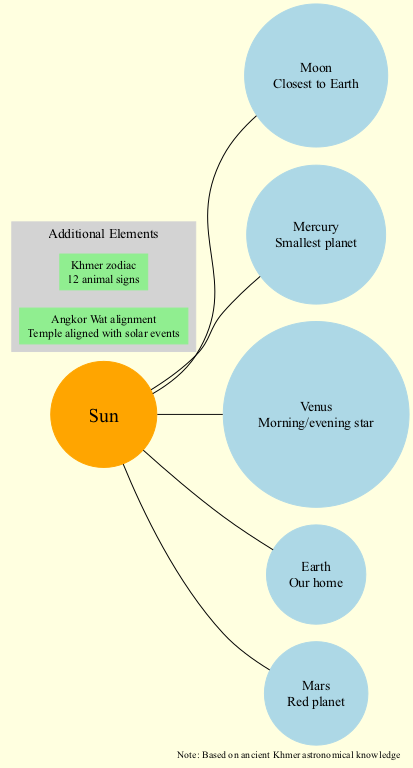What is the position of Venus in the diagram? The diagram indicates the position of Venus as 3. Each celestial body is listed with its corresponding position number, and Venus is clearly marked with position 3.
Answer: 3 How many celestial bodies are depicted in the solar system model? The diagram shows a total of 5 celestial bodies, which includes the Moon, Mercury, Venus, Earth, and Mars. By counting those listed under celestial bodies, we arrive at the total count of 5.
Answer: 5 Which celestial body is described as "Our home"? The Earth is the celestial body described as "Our home." In the diagram, it is explicitly indicated that Earth is associated with this description, distinguishing it from the other planets.
Answer: Earth What is the description of Mars in the diagram? Mars is described as the "Red planet." This information is directly taken from the diagram, where Mars is accompanied by its distinctive description, helping to identify its recognized characteristics.
Answer: Red planet Which additional element represents "Temple aligned with solar events"? The additional element that represents "Temple aligned with solar events" is "Angkor Wat alignment." In the diagram, this specific description is clearly associated with the "Angkor Wat alignment" node, showcasing a cultural significance in astronomy.
Answer: Angkor Wat alignment What celestial body is nearest to Earth? The closest celestial body to Earth, as per the diagram, is the Moon. This is indicated in the description for the Moon, which clearly states its proximity to Earth.
Answer: Moon Which is the smallest planet according to the diagram? Mercury is identified as the smallest planet. This piece of information is provided in the description associated with Mercury, establishing its size relative to other identified planets.
Answer: Mercury How many animal signs are included in the Khmer zodiac? The Khmer zodiac includes 12 animal signs. This information is derived from the description provided under the additional elements for the Khmer zodiac in the diagram.
Answer: 12 